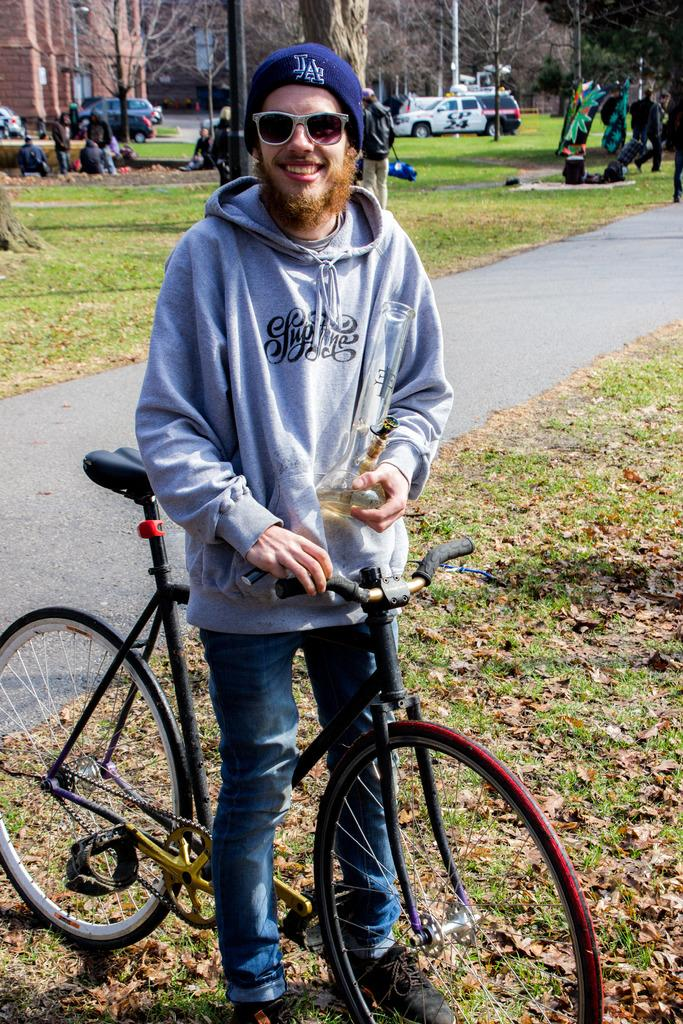Who is present in the image? There is a man in the image. What is the man doing in the image? The man is standing near a bicycle. What is the man holding in his hand? The man is holding a bottle in his hand. What can be seen in the background of the image? There is grass, a tree, a car, a group of people, and a building visible in the background of the image. What type of clouds can be seen in the image? There are no clouds visible in the image; the sky is not mentioned in the provided facts. 